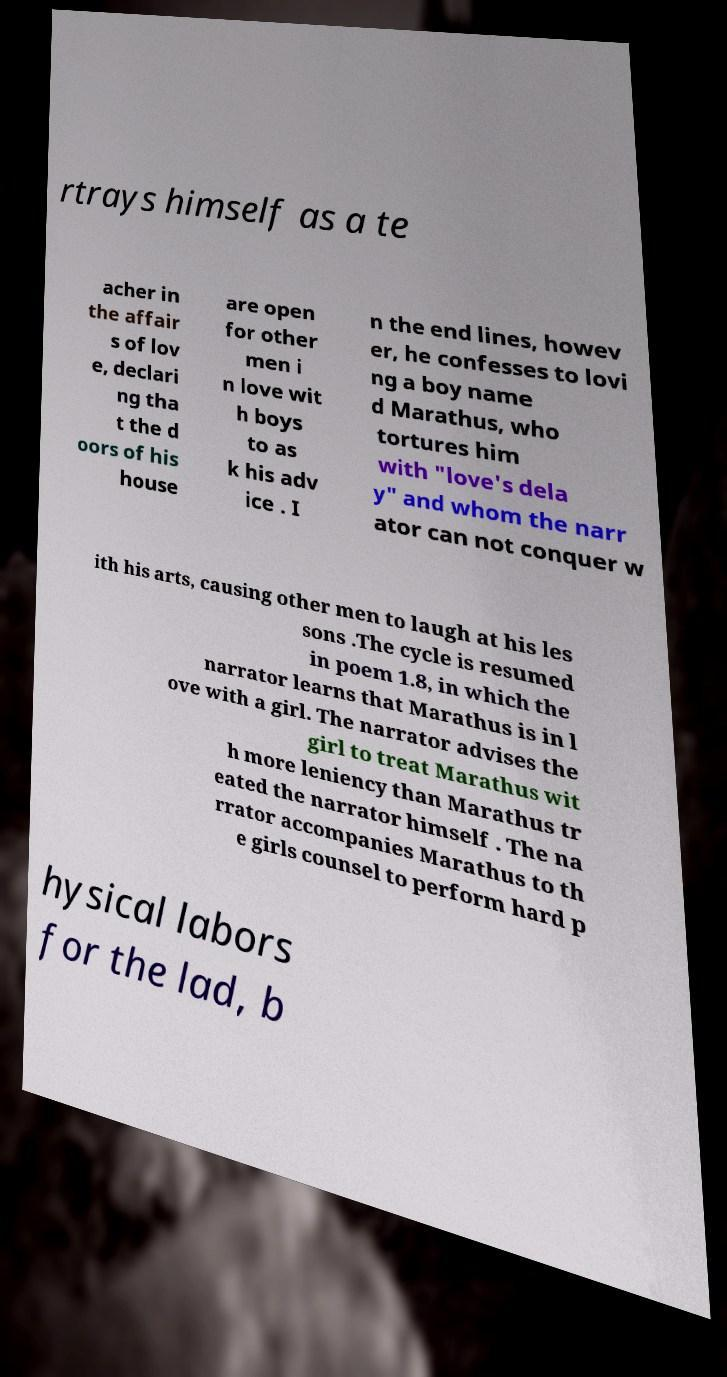Can you read and provide the text displayed in the image?This photo seems to have some interesting text. Can you extract and type it out for me? rtrays himself as a te acher in the affair s of lov e, declari ng tha t the d oors of his house are open for other men i n love wit h boys to as k his adv ice . I n the end lines, howev er, he confesses to lovi ng a boy name d Marathus, who tortures him with "love's dela y" and whom the narr ator can not conquer w ith his arts, causing other men to laugh at his les sons .The cycle is resumed in poem 1.8, in which the narrator learns that Marathus is in l ove with a girl. The narrator advises the girl to treat Marathus wit h more leniency than Marathus tr eated the narrator himself . The na rrator accompanies Marathus to th e girls counsel to perform hard p hysical labors for the lad, b 